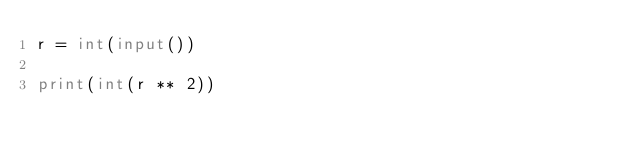<code> <loc_0><loc_0><loc_500><loc_500><_Python_>r = int(input())

print(int(r ** 2))</code> 